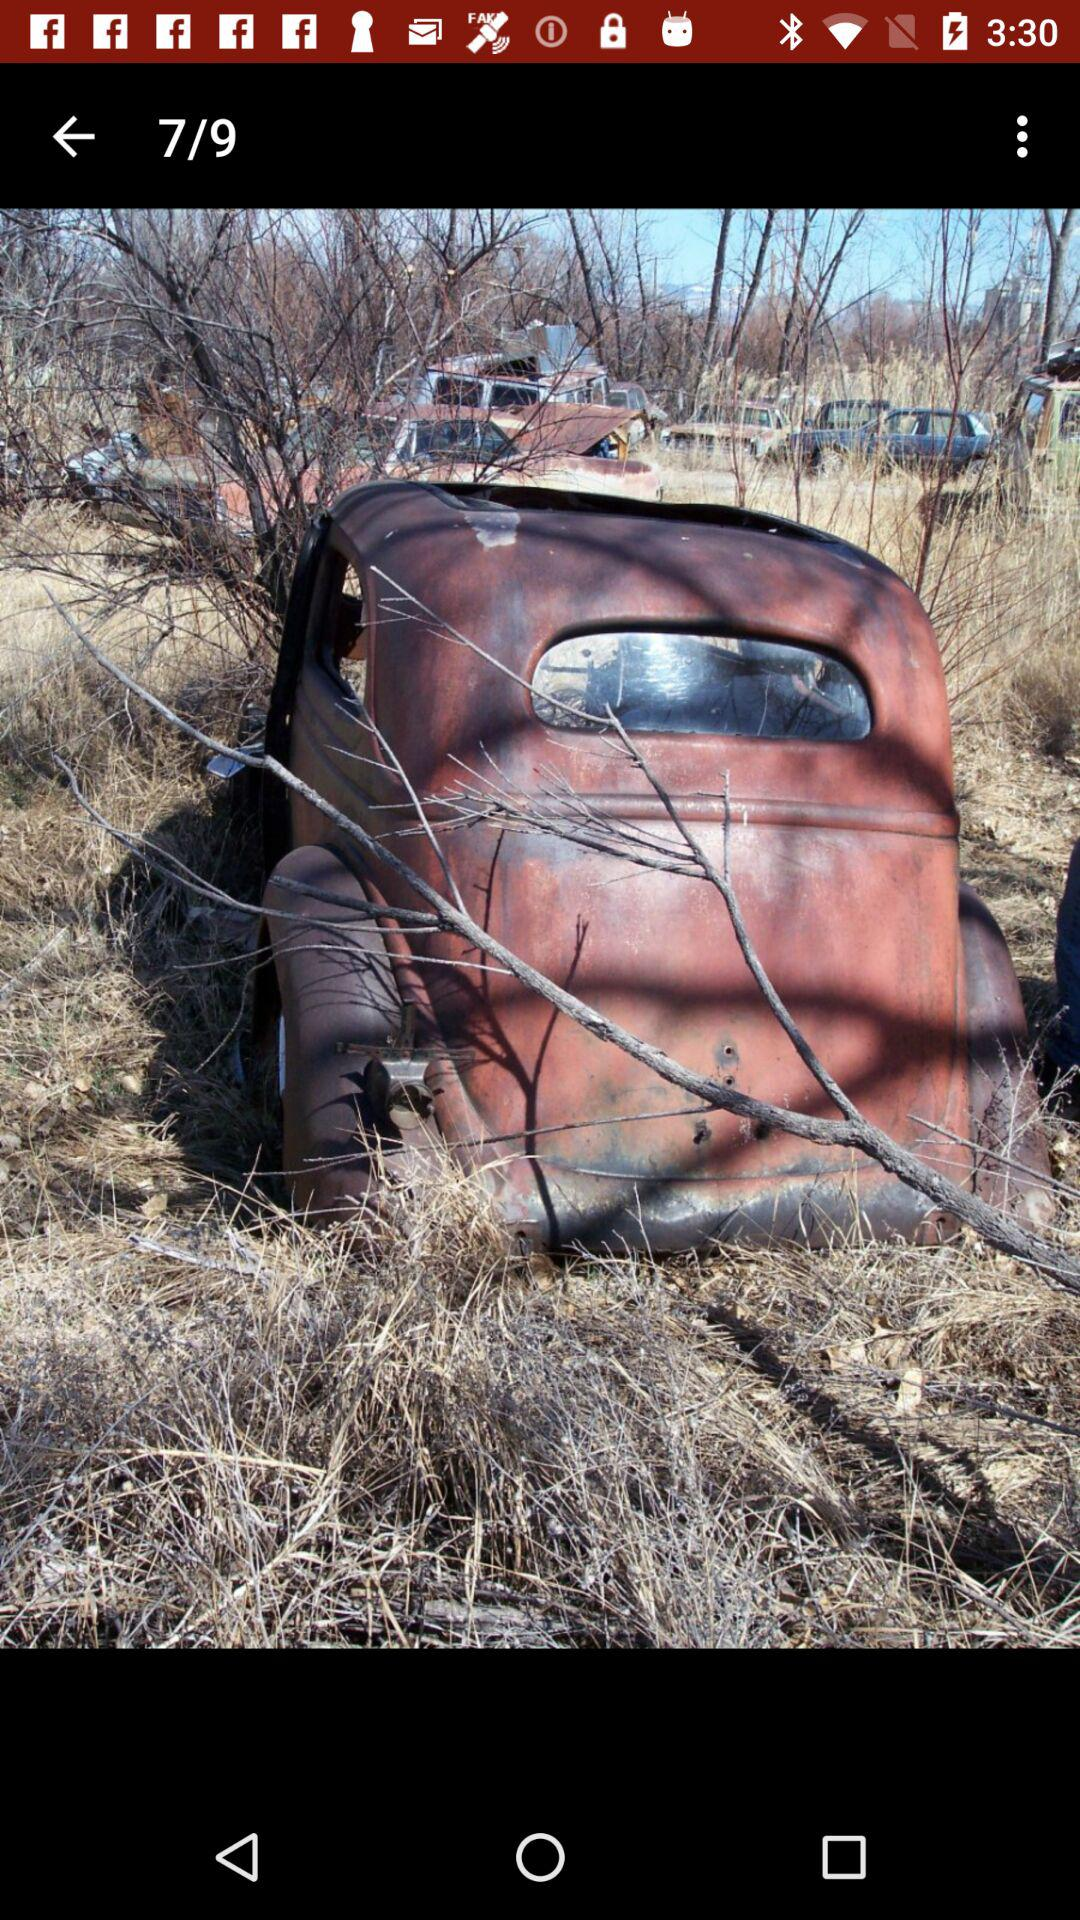How many images in total are there? There are 9 images. 